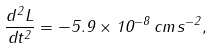<formula> <loc_0><loc_0><loc_500><loc_500>\frac { d ^ { 2 } L } { d t ^ { 2 } } = - 5 . 9 \times 1 0 ^ { - 8 } \, c m \, s ^ { - 2 } ,</formula> 